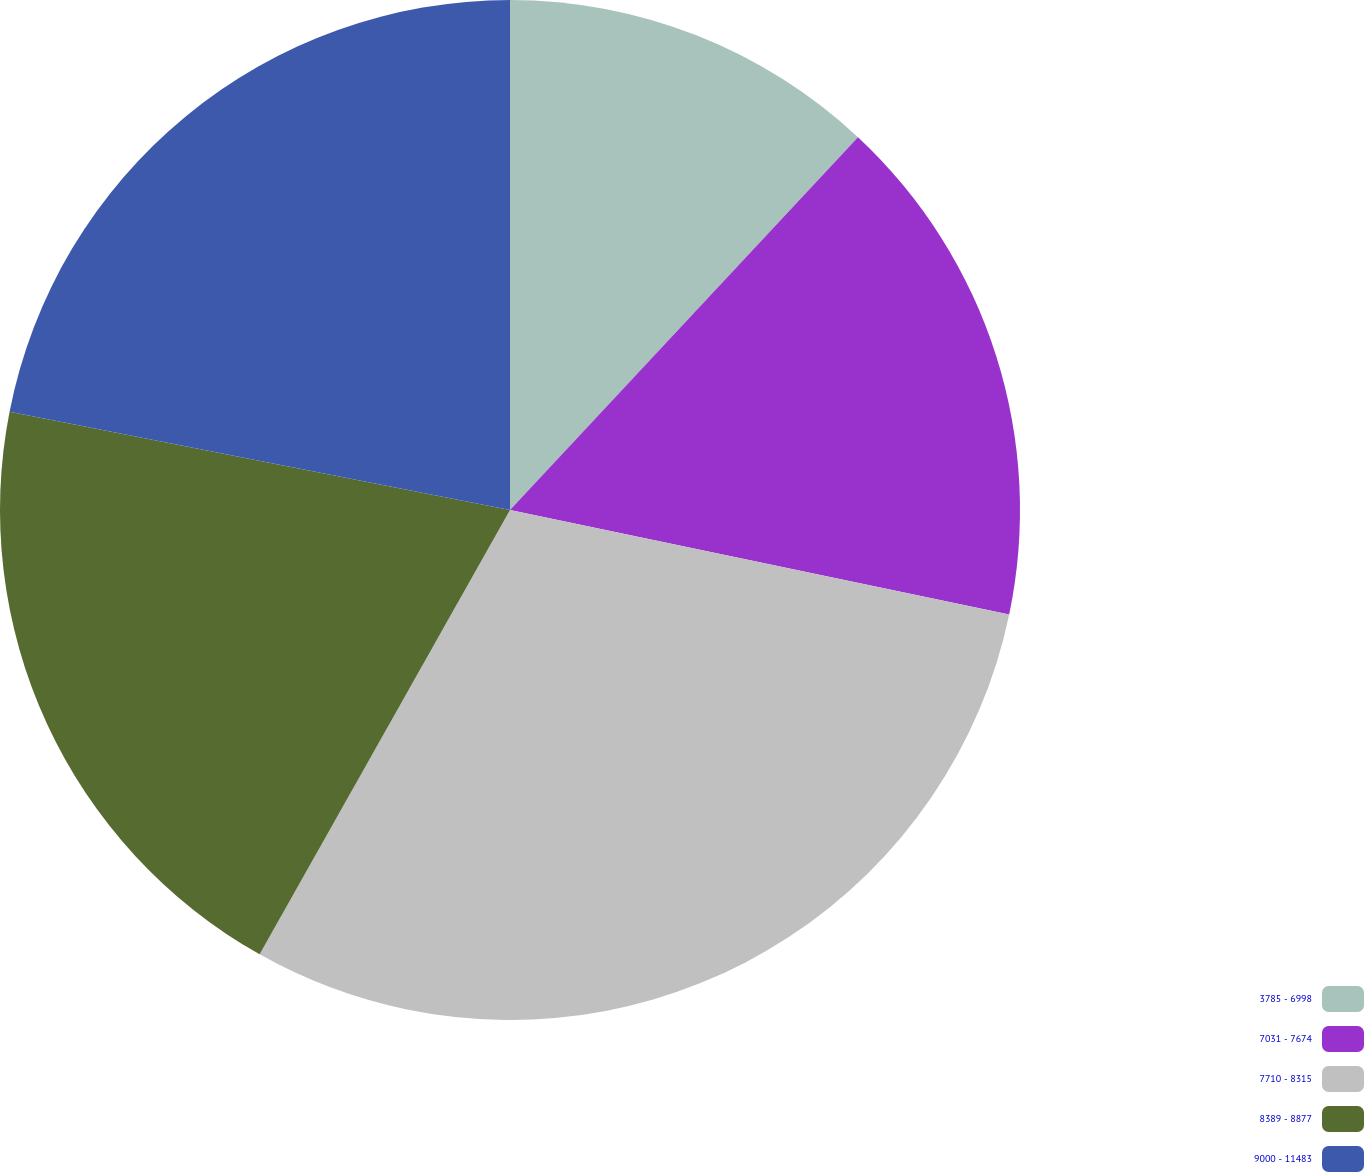Convert chart. <chart><loc_0><loc_0><loc_500><loc_500><pie_chart><fcel>3785 - 6998<fcel>7031 - 7674<fcel>7710 - 8315<fcel>8389 - 8877<fcel>9000 - 11483<nl><fcel>11.95%<fcel>16.33%<fcel>29.88%<fcel>19.92%<fcel>21.91%<nl></chart> 